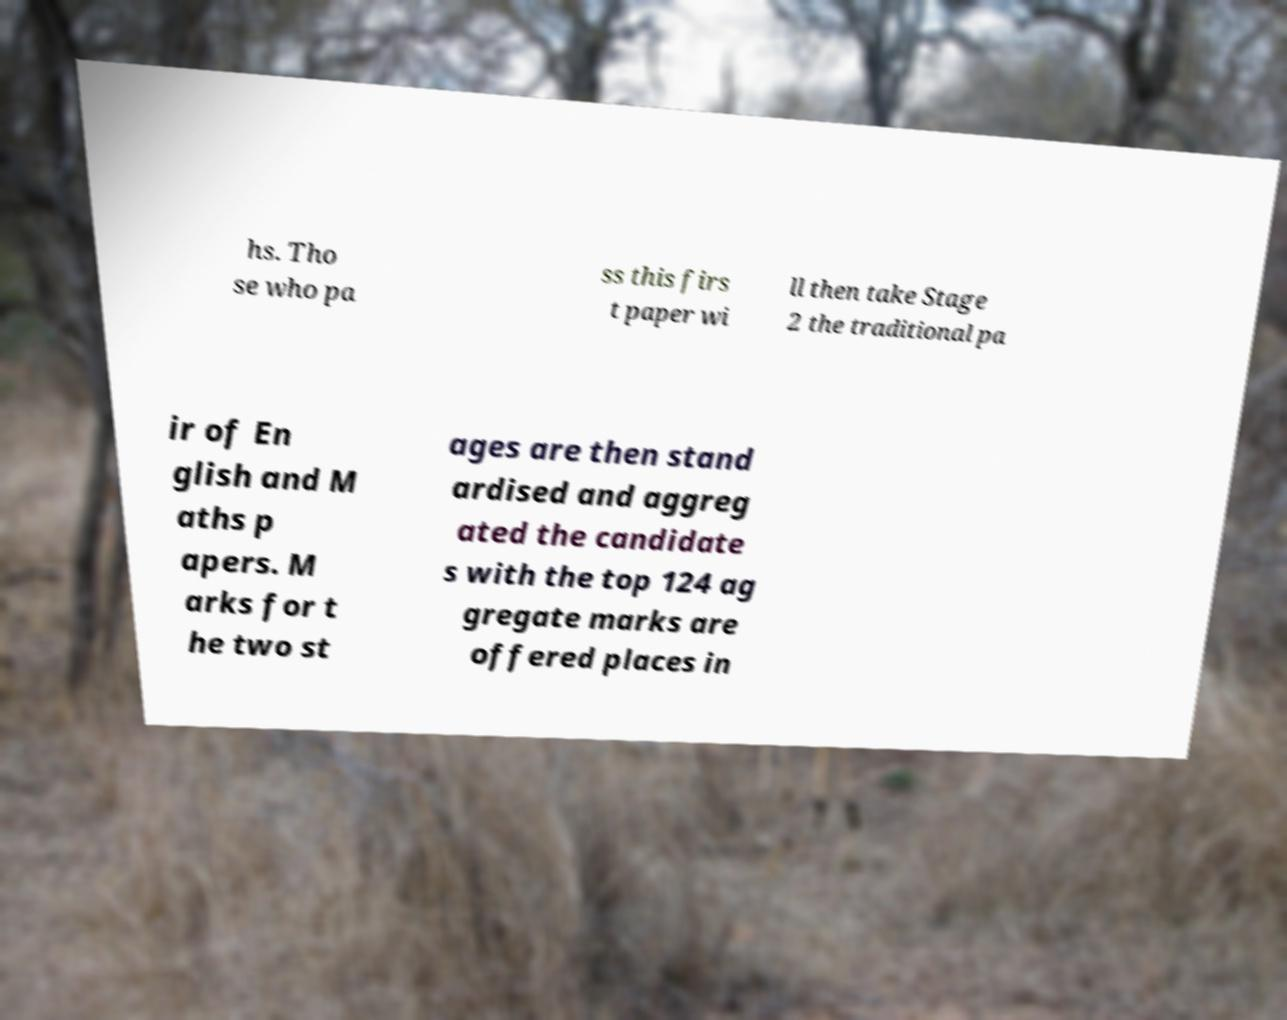There's text embedded in this image that I need extracted. Can you transcribe it verbatim? hs. Tho se who pa ss this firs t paper wi ll then take Stage 2 the traditional pa ir of En glish and M aths p apers. M arks for t he two st ages are then stand ardised and aggreg ated the candidate s with the top 124 ag gregate marks are offered places in 